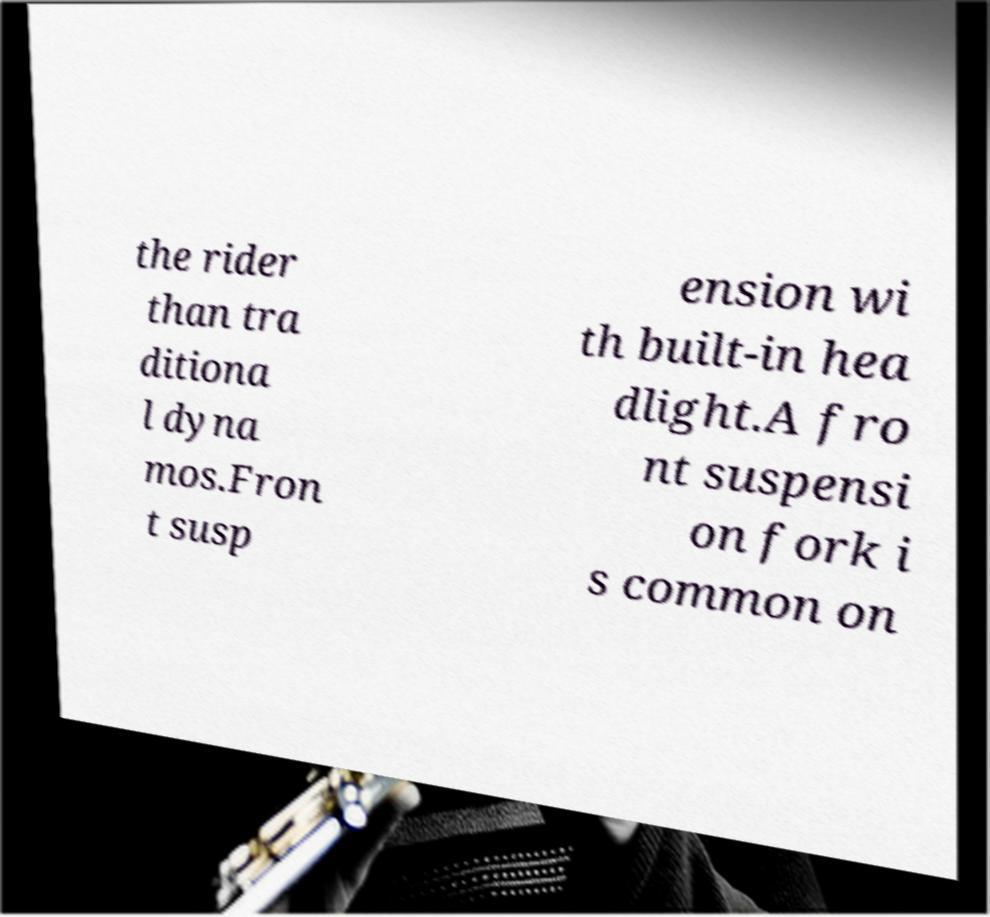Can you read and provide the text displayed in the image?This photo seems to have some interesting text. Can you extract and type it out for me? the rider than tra ditiona l dyna mos.Fron t susp ension wi th built-in hea dlight.A fro nt suspensi on fork i s common on 